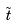Convert formula to latex. <formula><loc_0><loc_0><loc_500><loc_500>\tilde { t }</formula> 